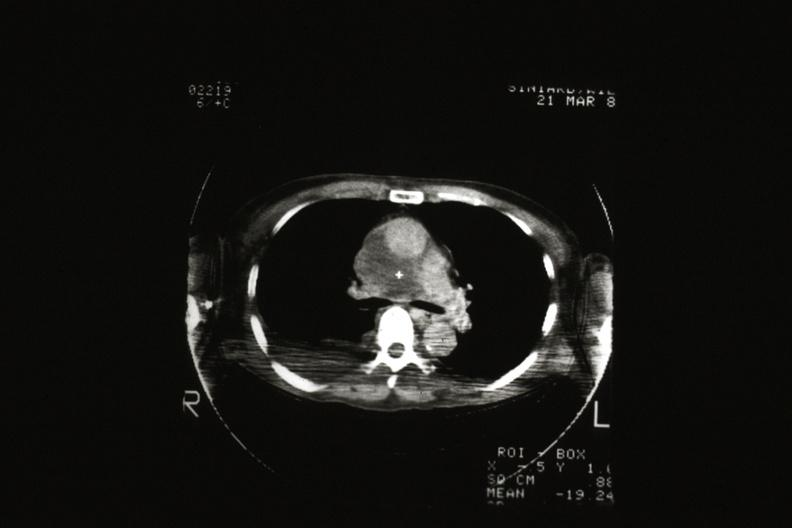s malignant thymoma present?
Answer the question using a single word or phrase. Yes 